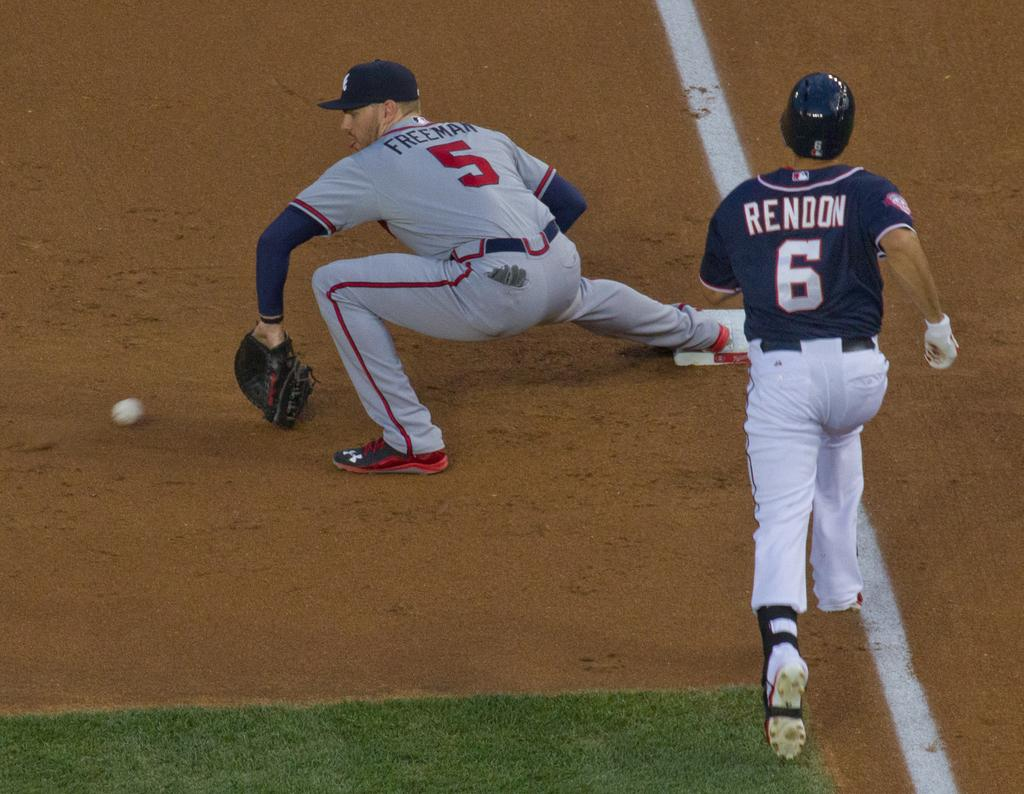<image>
Provide a brief description of the given image. Baseball player wearing number 6 running to base. 